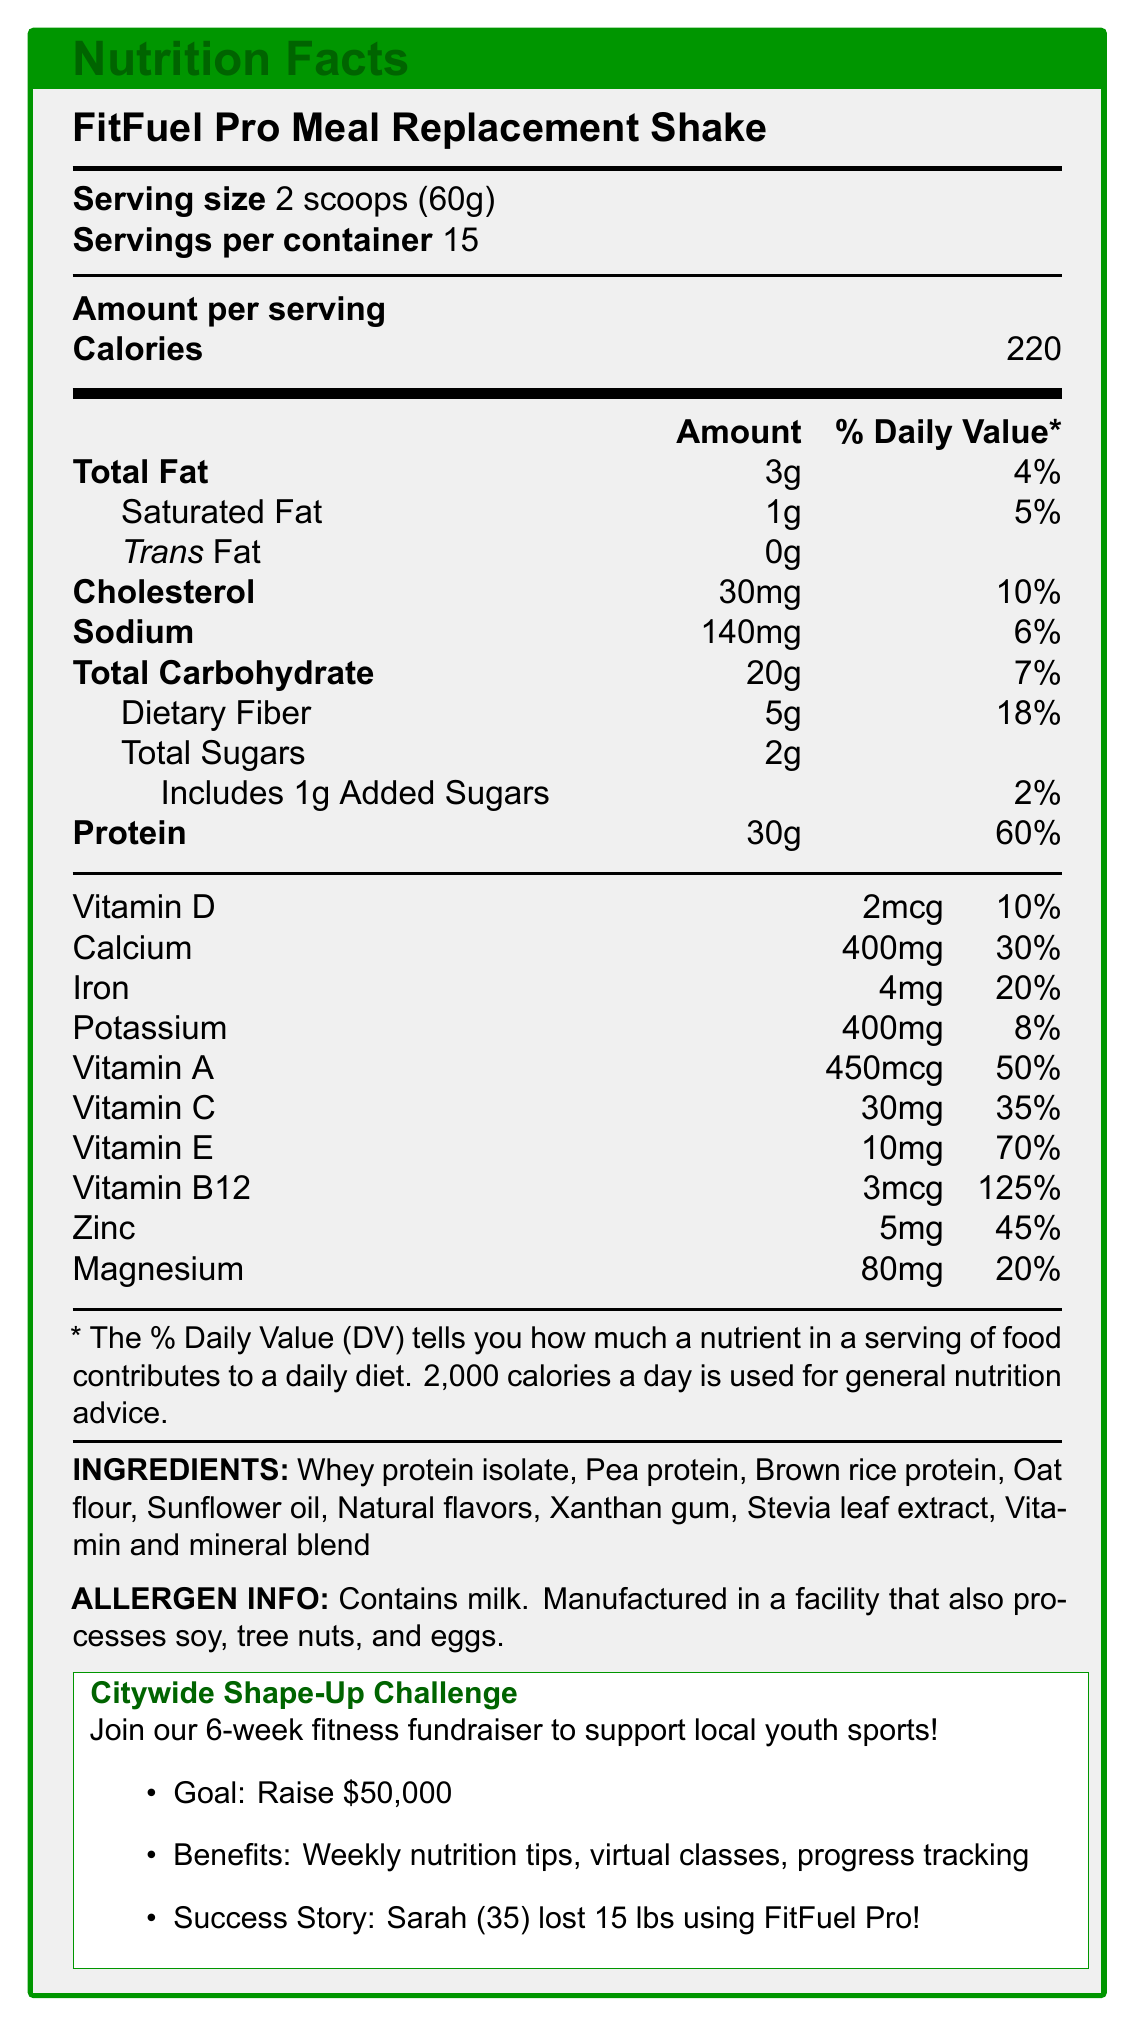what is the serving size of FitFuel Pro Meal Replacement Shake? The document specifies that the serving size for the FitFuel Pro Meal Replacement Shake is 2 scoops (60g).
Answer: 2 scoops (60g) how many calories are in one serving? The document shows that one serving of the FitFuel Pro Meal Replacement Shake contains 220 calories.
Answer: 220 What is the % Daily Value of protein per serving? The % Daily Value for protein per serving is listed as 60% in the nutrition facts.
Answer: 60% Does the product contain any trans fat? The document indicates that there are 0g of trans fat per serving.
Answer: No how much dietary fiber is in one serving? According to the document, each serving contains 5g of dietary fiber.
Answer: 5g How many servings are there per container? The document states that there are 15 servings per container.
Answer: 15 Does the product support any local community initiative? The product is promoted as part of the Citywide Shape-Up Challenge, which aims to support local youth sports programs.
Answer: Yes What are the main features of the FitFuel Pro Meal Replacement Shake? The document details these features in the product description section and the nutrition facts.
Answer: FitFuel Pro Meal Replacement Shake is a high-protein, nutrient-dense shake with 30g of protein, essential vitamins and minerals, 5g of fiber, and 220 calories per serving. How much sodium does one serving contain? The document lists the sodium content as 140mg per serving.
Answer: 140mg Can the exact amount of sunflower oil be determined from the document? The document lists sunflower oil as an ingredient, but does not specify the amount.
Answer: No Who provided a testimonial for the product? The document includes a success story from Sarah Johnson, age 35.
Answer: Sarah Johnson What is the main goal of the Citywide Shape-Up Challenge? The document states that the goal of the challenge is to raise $50,000 for local youth sports programs.
Answer: Raise $50,000 for local youth sports programs What are the added sugars in one serving and their % Daily Value? The document specifies that there is 1g of added sugars per serving, which contributes to 2% of the Daily Value.
Answer: 1g, 2% What benefits do participants of the Citywide Shape-Up Challenge receive? A. Weekly nutrition tips B. Virtual fitness classes C. Progress tracking app D. All of the above The document mentions that participants receive weekly nutrition tips, virtual fitness classes, and a progress tracking app.
Answer: D How much calcium is in one serving of the shake? The document shows that each serving contains 400mg of calcium.
Answer: 400mg Does the product contain any natural flavors? Natural flavors are listed as an ingredient in the product.
Answer: Yes What is the weight loss achievement of Sarah Johnson during the Shape-Up Challenge? The document mentions that Sarah Johnson lost 15 pounds using the FitFuel Pro shakes during the Shape-Up Challenge.
Answer: 15 pounds Summarize the main idea of the document. The summary includes all major points from the nutrition facts, ingredient list, product description, fitness challenge goals, and success story provided in the document.
Answer: The document provides detailed nutrition facts, ingredients, and allergen information for the FitFuel Pro Meal Replacement Shake, which is promoted during the Citywide Shape-Up Challenge fundraiser. The product is designed to support fitness goals with high protein and essential nutrients. The challenge aims to raise $50,000 for local youth sports programs, offering participants various benefits, and includes a success story from Sarah Johnson. 